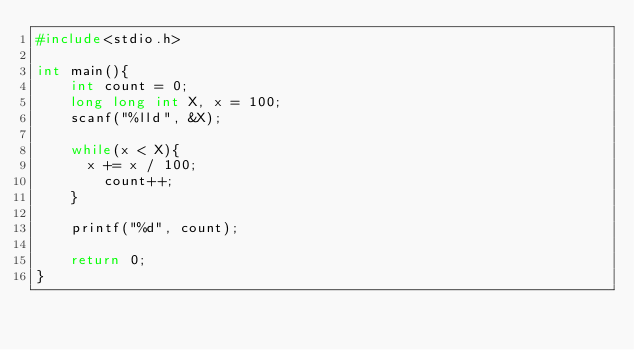Convert code to text. <code><loc_0><loc_0><loc_500><loc_500><_C_>#include<stdio.h>
 
int main(){
	int count = 0; 
	long long int X, x = 100;
	scanf("%lld", &X);
  
	while(x < X){
      x += x / 100;
		count++;
    }
 
	printf("%d", count);
 
	return 0;
}</code> 